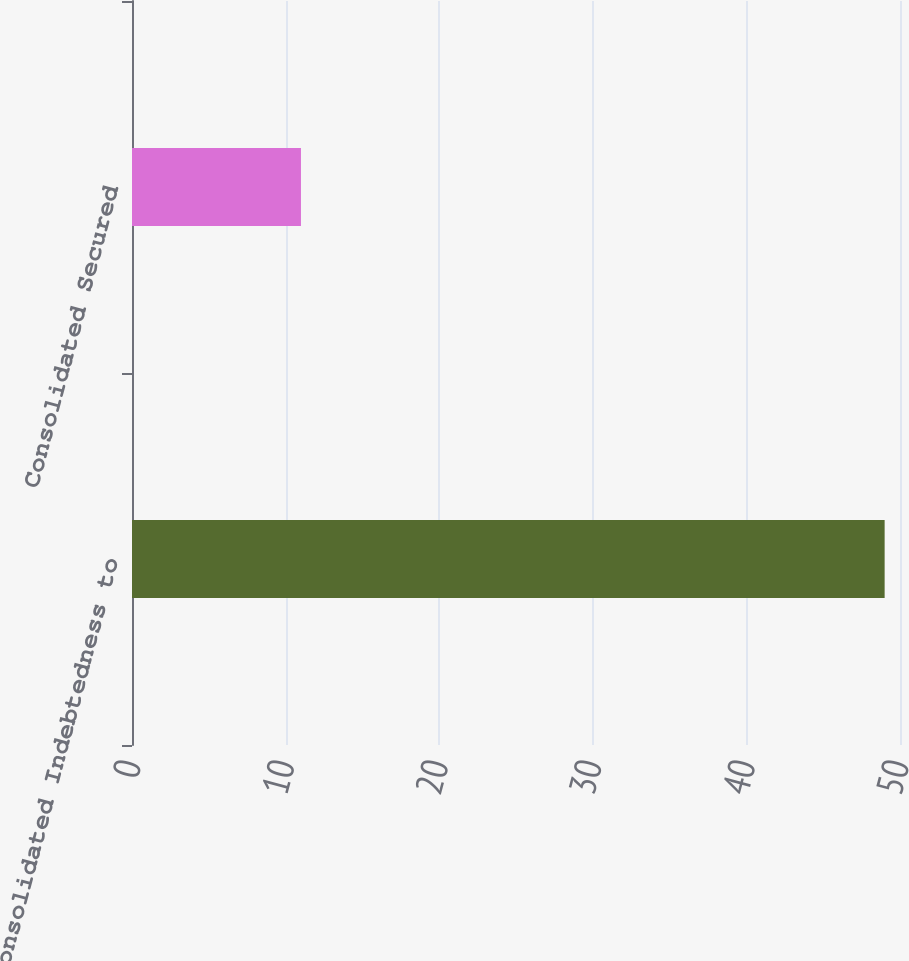Convert chart. <chart><loc_0><loc_0><loc_500><loc_500><bar_chart><fcel>Consolidated Indebtedness to<fcel>Consolidated Secured<nl><fcel>49<fcel>11<nl></chart> 